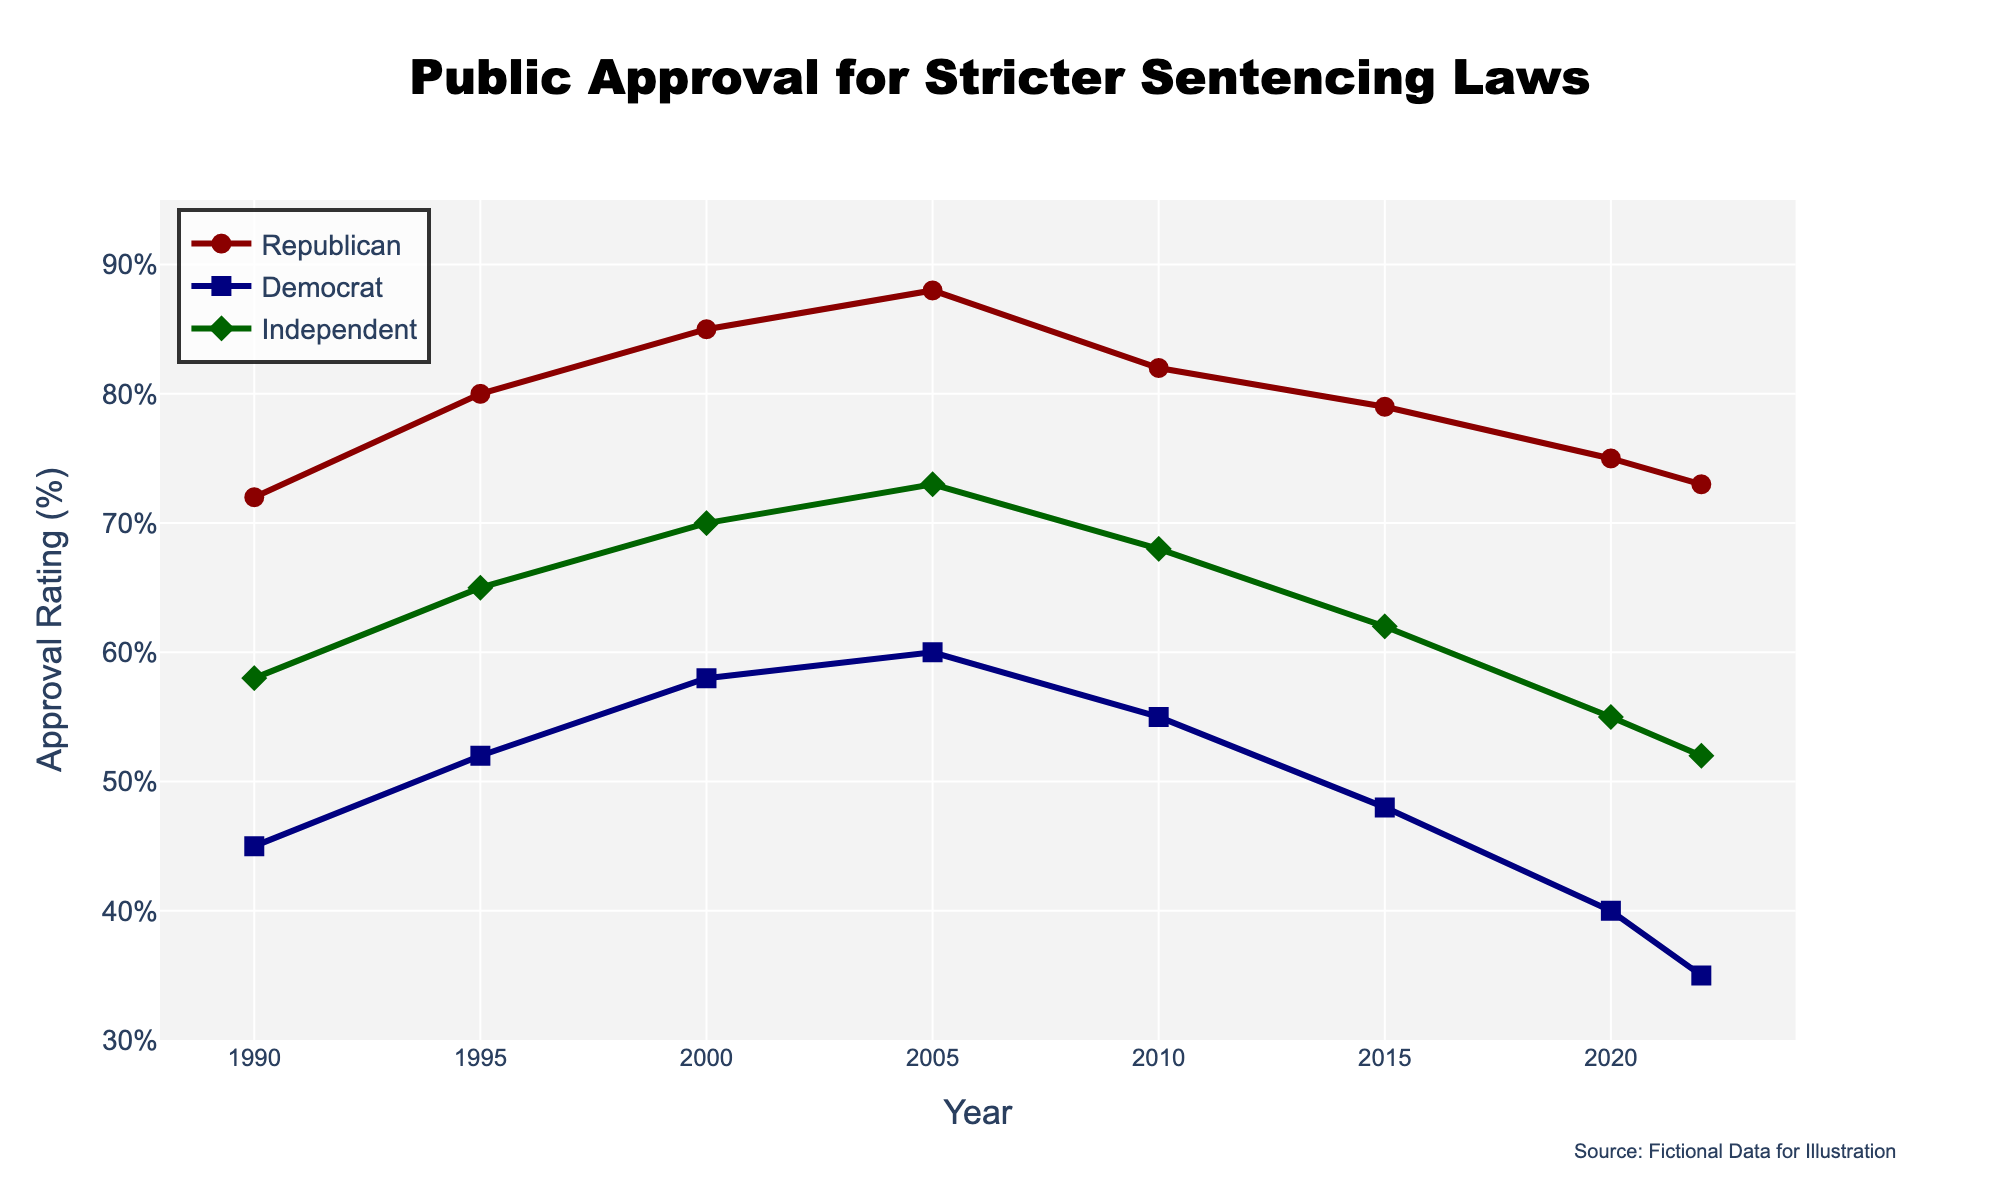What's the trend for Republican approval ratings from 1990 to 2022? From 1990 to 2005, Republican approval ratings increase from 72% to 88%. From 2005 to 2022, ratings decline to 73%. So, there's an overall increase followed by a decrease.
Answer: Increase then decrease Which political affiliation had the highest approval rating in 2020? In 2020, the Republican approval rating was 75%, Democrat was 40%, and Independent was 55%. Republicans had the highest approval rating.
Answer: Republican Calculate the average approval rating for Democrats from 1990 to 2022. Sum Democrat ratings: 45 + 52 + 58 + 60 + 55 + 48 + 40 + 35 = 393. There are 8 data points, so the average is 393 / 8 = 49.125%.
Answer: 49.125% Which group's approval rating decreased the most between 2010 and 2022? For Republicans, the decrease: 82% - 73% = 9%. For Democrats: 55% - 35% = 20%. For Independents: 68% - 52% = 16%. Democrats had the highest decrease.
Answer: Democrat Is the approval rating of Independents in 2022 higher than the approval rating of Democrats at any point in the given period? In 2022, Independents showed a 52% approval rating. Democrats never reached 52% as the highest was 60% in 2005, and the rest were lower.
Answer: No What’s the gap between the highest and lowest approval ratings for Republicans? Highest for Republicans is 88% (2005) and the lowest is 72% (1990), the difference: 88 - 72 = 16%.
Answer: 16% Which political affiliation saw the smallest change in approval ratings from 1990 to 2022? Change for Republicans: 73 - 72 = 1%. Change for Democrats: 35 - 45 = -10%. Change for Independents: 52 - 58 = -6%. Republicans saw the smallest change.
Answer: Republican Compare the approval rating of Independents in 2000 with Republicans in 2020. In 2000, Independents had a 70% rating, while Republicans had a 75% rating in 2020. Republicans had a higher rating.
Answer: Republicans Which year shows the greatest difference between Democrat and Republican approval ratings? In 2005, Democrat rating: 60%, Republican rating: 88%, difference: 28%. This is the largest difference.
Answer: 2005 Does the Republican approval rating in 2010 exceed the highest Democrat approval rating from 1990 to 2022? Republican approval rating in 2010 is 82%. The highest Democrat rating is 60% in 2005. Thus, 82% > 60%.
Answer: Yes 